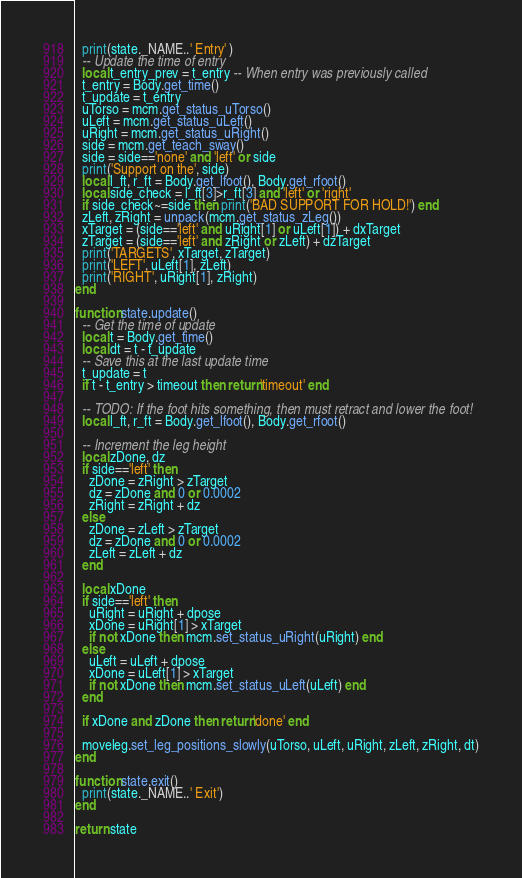Convert code to text. <code><loc_0><loc_0><loc_500><loc_500><_Lua_>  print(state._NAME..' Entry' )
  -- Update the time of entry
  local t_entry_prev = t_entry -- When entry was previously called
  t_entry = Body.get_time()
  t_update = t_entry
  uTorso = mcm.get_status_uTorso()  
  uLeft = mcm.get_status_uLeft()
  uRight = mcm.get_status_uRight()
  side = mcm.get_teach_sway()
  side = side=='none' and 'left' or side
  print('Support on the', side)
  local l_ft, r_ft = Body.get_lfoot(), Body.get_rfoot()
  local side_check = l_ft[3]>r_ft[3] and 'left' or 'right'
  if side_check~=side then print('BAD SUPPORT FOR HOLD!') end
  zLeft, zRight = unpack(mcm.get_status_zLeg())
  xTarget = (side=='left' and uRight[1] or uLeft[1]) + dxTarget
  zTarget = (side=='left' and zRight or zLeft) + dzTarget
  print('TARGETS', xTarget, zTarget)
  print('LEFT', uLeft[1], zLeft)
  print('RIGHT', uRight[1], zRight)
end

function state.update()
  -- Get the time of update
  local t = Body.get_time()
  local dt = t - t_update
  -- Save this at the last update time
  t_update = t
  if t - t_entry > timeout then return'timeout' end
  
  -- TODO: If the foot hits something, then must retract and lower the foot!
  local l_ft, r_ft = Body.get_lfoot(), Body.get_rfoot()
  
  -- Increment the leg height
  local zDone, dz
  if side=='left' then
    zDone = zRight > zTarget
    dz = zDone and 0 or 0.0002
    zRight = zRight + dz
  else
    zDone = zLeft > zTarget
    dz = zDone and 0 or 0.0002
    zLeft = zLeft + dz
  end
  
  local xDone
  if side=='left' then
    uRight = uRight + dpose
    xDone = uRight[1] > xTarget
    if not xDone then mcm.set_status_uRight(uRight) end
  else
    uLeft = uLeft + dpose
    xDone = uLeft[1] > xTarget
    if not xDone then mcm.set_status_uLeft(uLeft) end
  end
  
  if xDone and zDone then return'done' end
  
  moveleg.set_leg_positions_slowly(uTorso, uLeft, uRight, zLeft, zRight, dt)
end

function state.exit()
  print(state._NAME..' Exit')
end

return state
</code> 